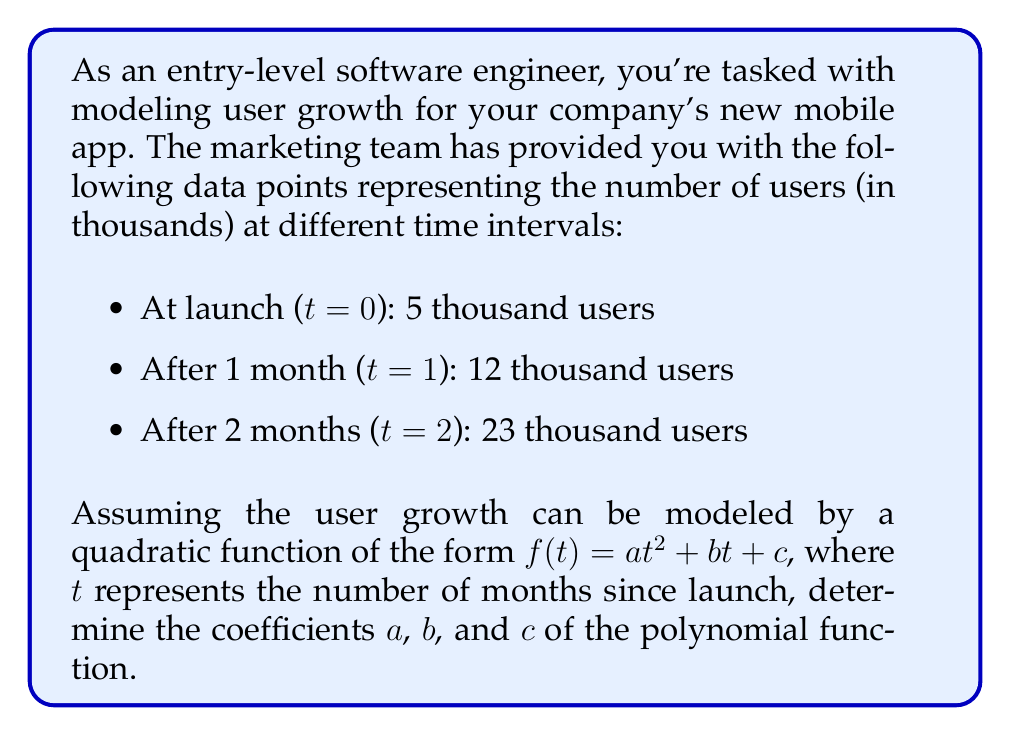Help me with this question. To solve this problem, we'll use the given data points to create a system of equations and then solve for the coefficients $a$, $b$, and $c$. Let's follow these steps:

1. Set up the system of equations:
   Using the general form $f(t) = at^2 + bt + c$, we can create three equations based on the given data points:

   For t = 0: $5 = a(0)^2 + b(0) + c$
   For t = 1: $12 = a(1)^2 + b(1) + c$
   For t = 2: $23 = a(2)^2 + b(2) + c$

2. Simplify the equations:
   $5 = c$
   $12 = a + b + c$
   $23 = 4a + 2b + c$

3. Substitute $c = 5$ into the other two equations:
   $12 = a + b + 5$
   $23 = 4a + 2b + 5$

4. Simplify:
   $7 = a + b$
   $18 = 4a + 2b$

5. Multiply the first equation by 2:
   $14 = 2a + 2b$

6. Subtract this from the second equation:
   $18 - 14 = (4a + 2b) - (2a + 2b)$
   $4 = 2a$

7. Solve for $a$:
   $a = 2$

8. Substitute $a = 2$ into $7 = a + b$:
   $7 = 2 + b$
   $b = 5$

9. Recall that $c = 5$

Therefore, the coefficients of the quadratic function $f(t) = at^2 + bt + c$ are:
$a = 2$, $b = 5$, and $c = 5$
Answer: $a = 2$, $b = 5$, $c = 5$

The quadratic function modeling user growth is:
$$f(t) = 2t^2 + 5t + 5$$
where $f(t)$ represents the number of users in thousands, and $t$ represents the number of months since launch. 